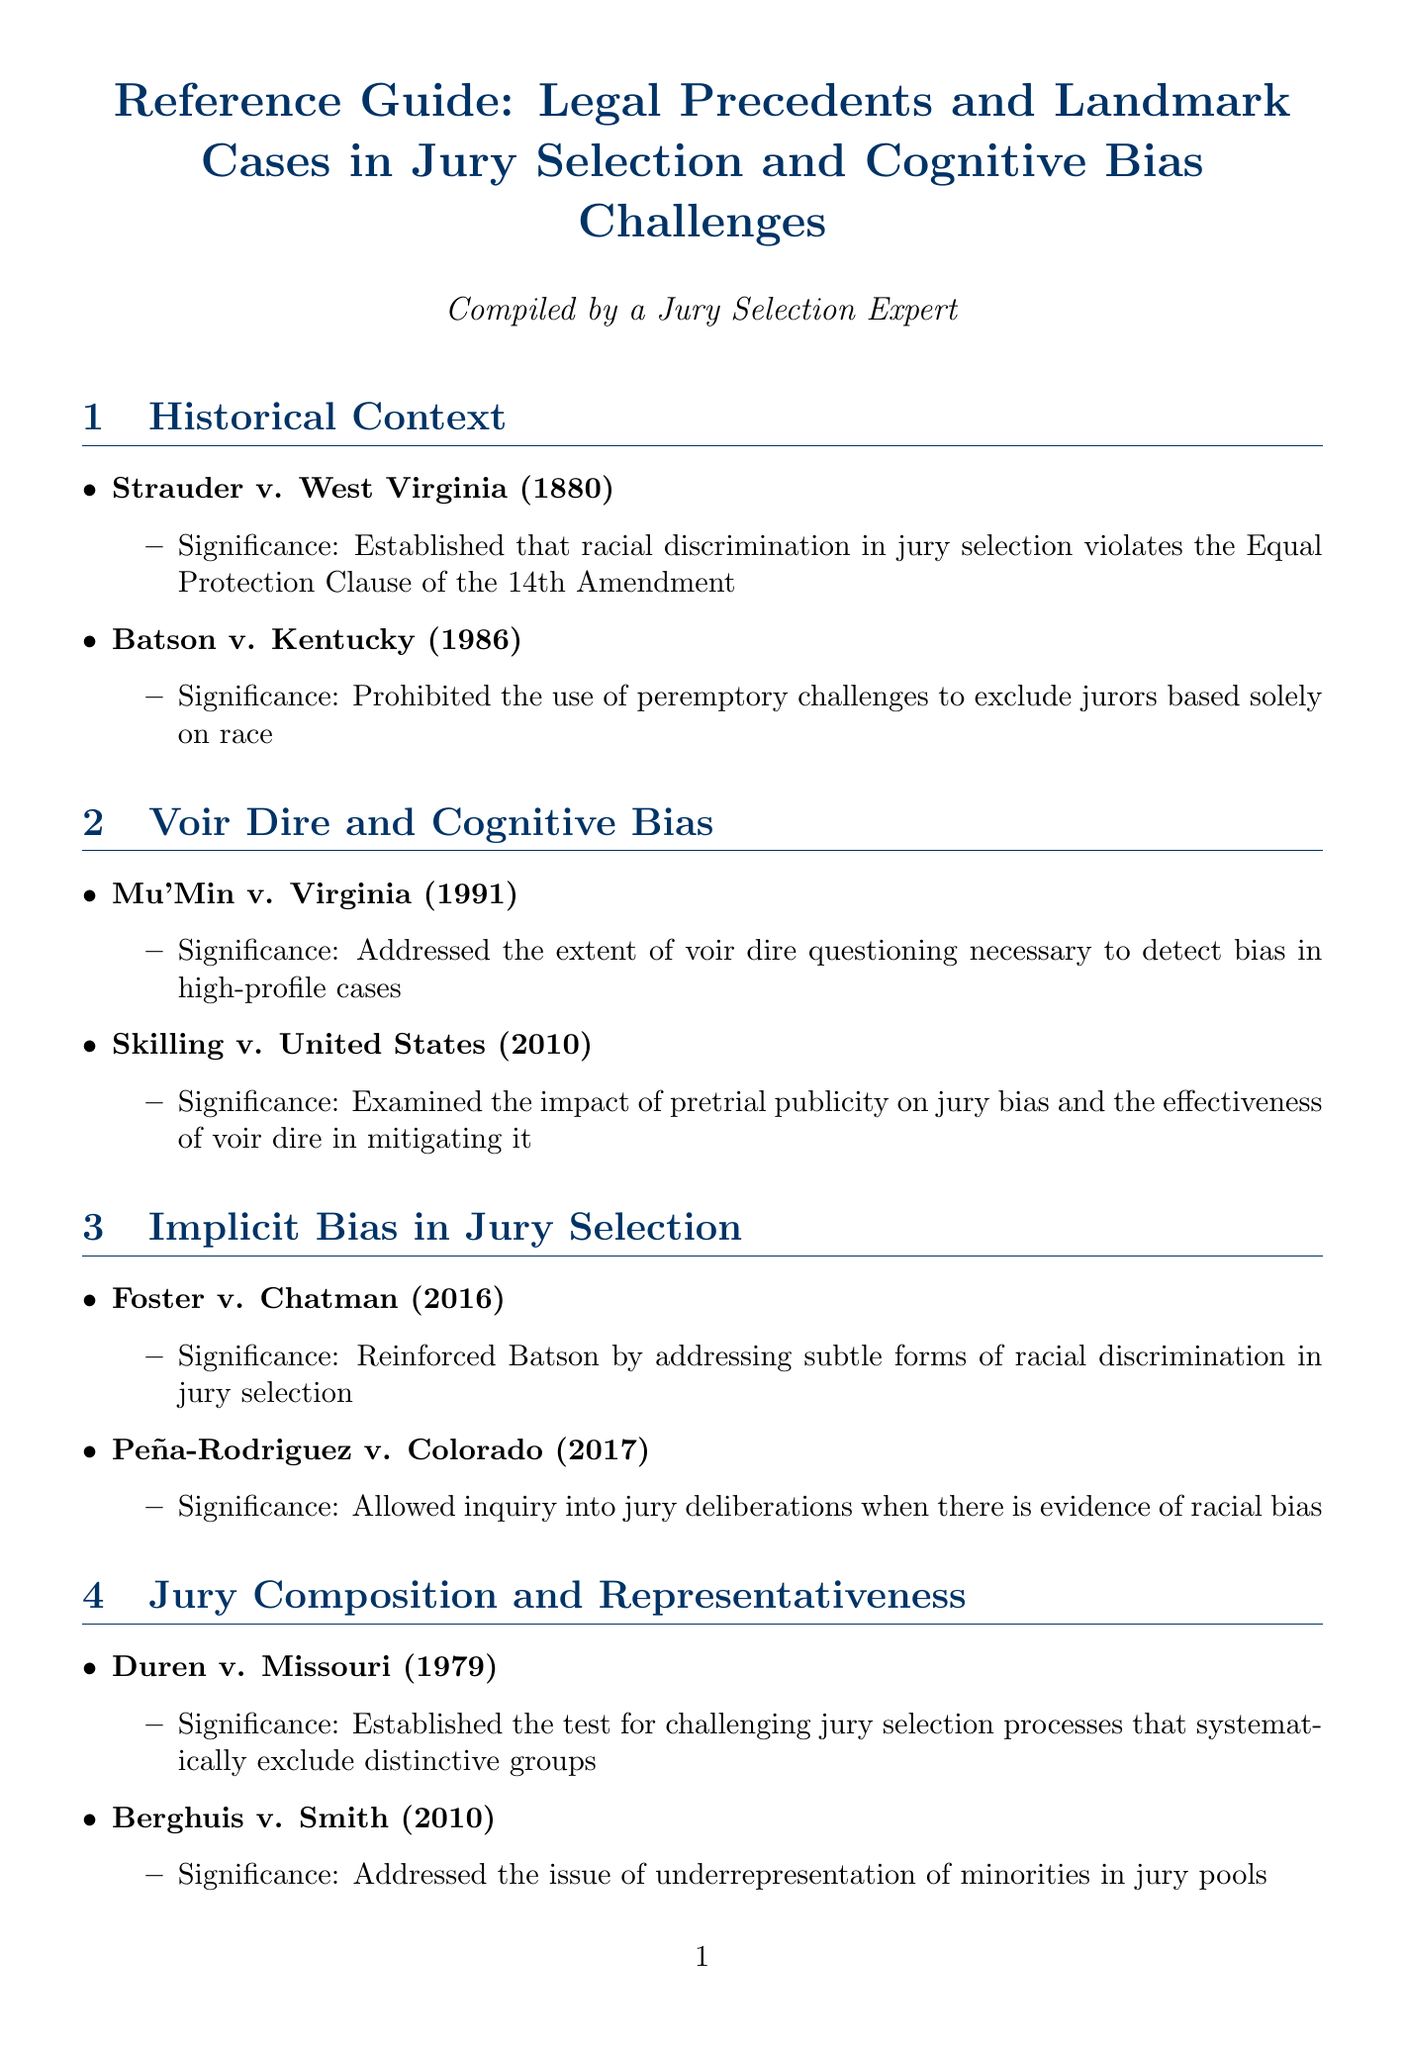What is the title of the document? The title is provided at the beginning of the document to indicate the subject matter it covers.
Answer: Reference Guide: Legal Precedents and Landmark Cases in Jury Selection and Cognitive Bias Challenges What case established that racial discrimination in jury selection violates the Equal Protection Clause? This information is found in the Historical Context section, listing significant cases related to jury selection.
Answer: Strauder v. West Virginia In which year was Batson v. Kentucky decided? The document includes the case name and the year of its decision in the Historical Context section.
Answer: 1986 What landmark case addressed the impact of pretrial publicity on jury bias? This question refers to the case mentioned in the Voir Dire and Cognitive Bias section focusing on the effects of pretrial publicity.
Answer: Skilling v. United States Which case allowed inquiry into jury deliberations when there is evidence of racial bias? Located in the Implicit Bias in Jury Selection section, this case is significant for its implications on race in jury deliberations.
Answer: Peña-Rodriguez v. Colorado What test did Duren v. Missouri establish? This question relates to challenges in jury selection, as discussed in the Jury Composition and Representativeness section.
Answer: The test for challenging jury selection processes that systematically exclude distinctive groups What is the significance of Flowers v. Mississippi? The case is mentioned in the Recent Developments and Future Directions section and highlights important legal principles related to jury selection.
Answer: Reaffirmed the importance of Batson challenges and scrutinized patterns of discriminatory jury selection What is an emerging area of law in jury selection mentioned in the document? The document discusses current trends and topics in the context of jury selection, including unique methodologies.
Answer: Use of Scientific Jury Selection Methods How many cases are listed under the Cognitive Biases in Trial Proceedings section? This question pertains to the number of significant cases discussed in that specific section of the document.
Answer: Two 